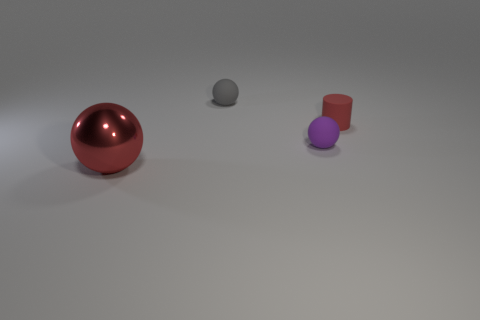Is there any indication of the objects' purpose or function within this scene? The objects' purpose is not clear from the scene. They appear to be placed for display, possibly for an artistic composition or for demonstrating lighting and shading in a 3D rendering context. 